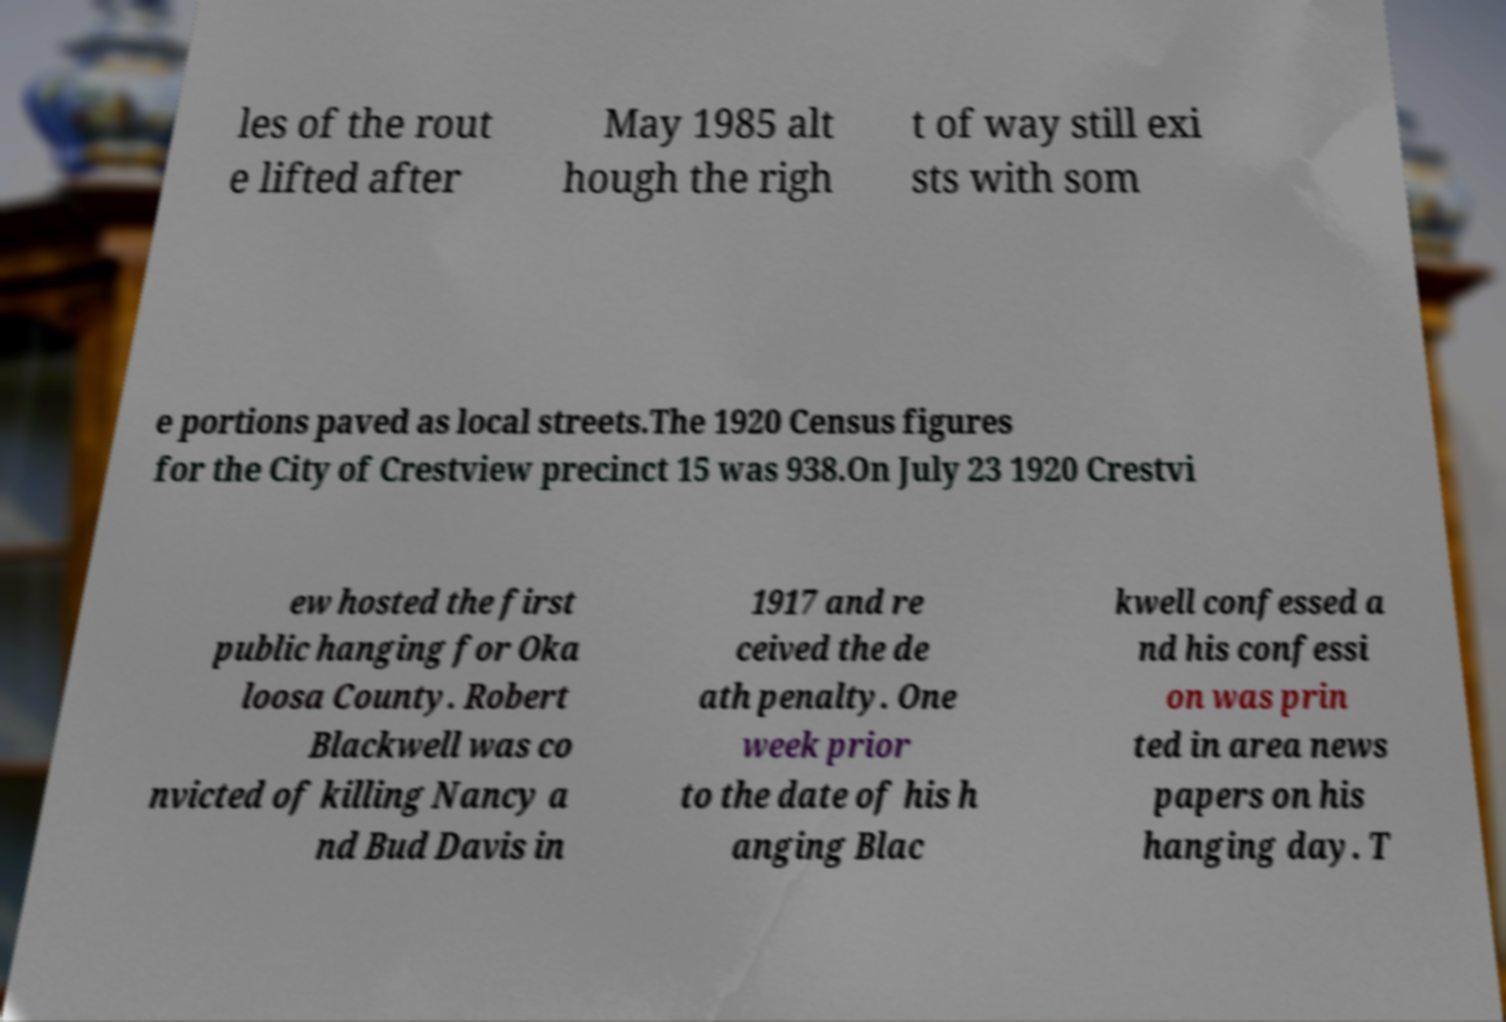I need the written content from this picture converted into text. Can you do that? les of the rout e lifted after May 1985 alt hough the righ t of way still exi sts with som e portions paved as local streets.The 1920 Census figures for the City of Crestview precinct 15 was 938.On July 23 1920 Crestvi ew hosted the first public hanging for Oka loosa County. Robert Blackwell was co nvicted of killing Nancy a nd Bud Davis in 1917 and re ceived the de ath penalty. One week prior to the date of his h anging Blac kwell confessed a nd his confessi on was prin ted in area news papers on his hanging day. T 